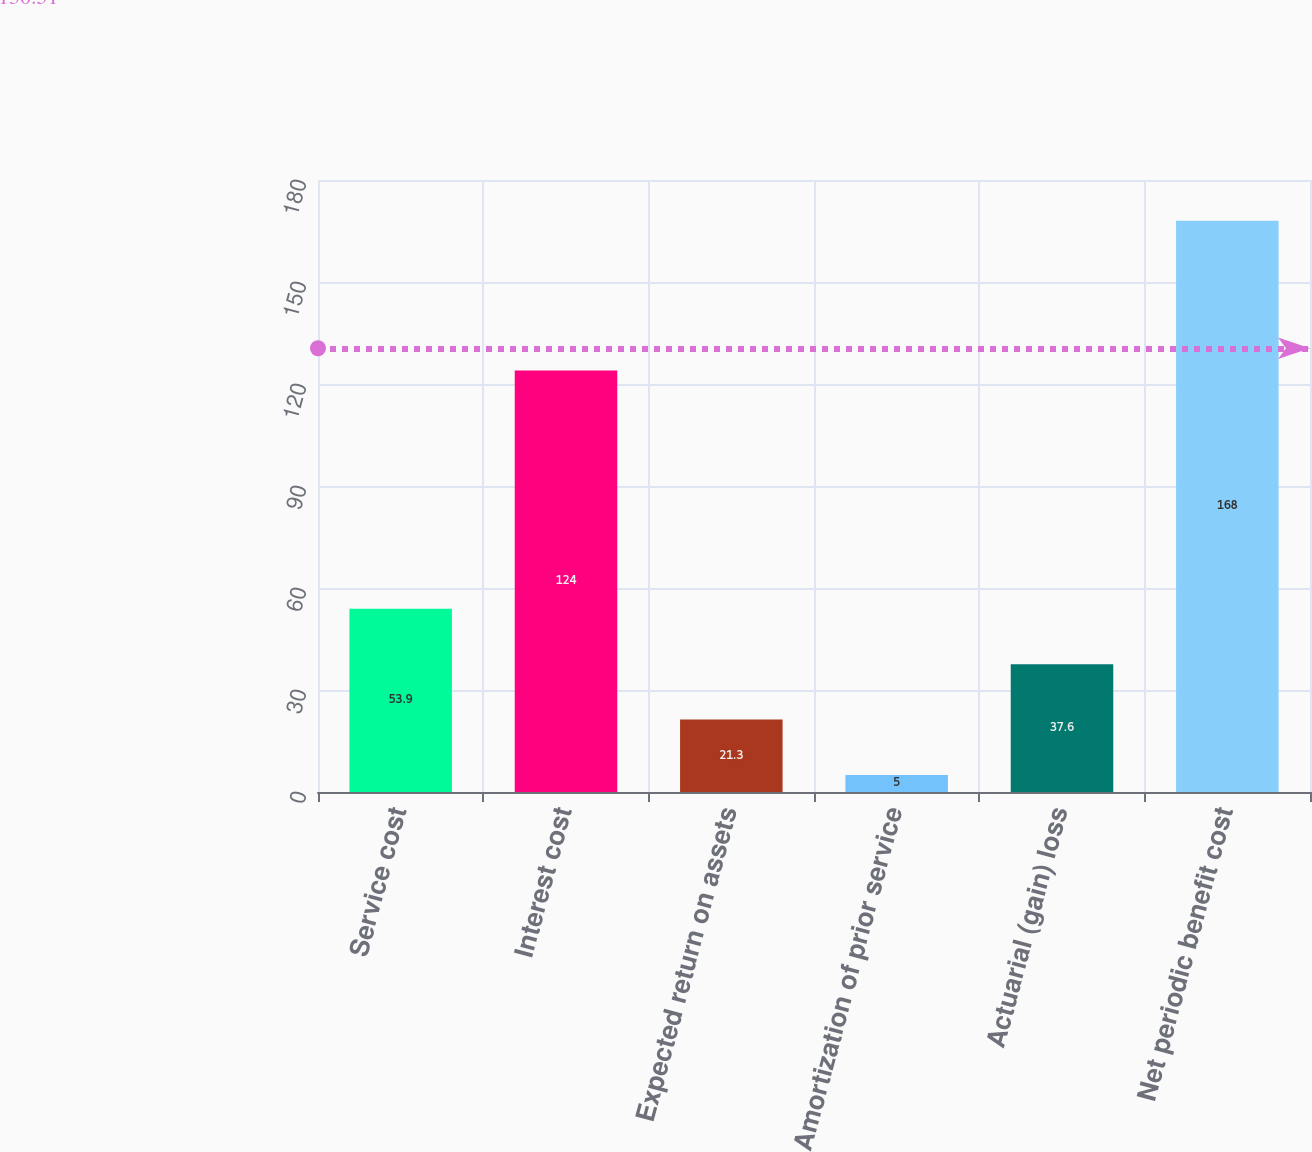<chart> <loc_0><loc_0><loc_500><loc_500><bar_chart><fcel>Service cost<fcel>Interest cost<fcel>Expected return on assets<fcel>Amortization of prior service<fcel>Actuarial (gain) loss<fcel>Net periodic benefit cost<nl><fcel>53.9<fcel>124<fcel>21.3<fcel>5<fcel>37.6<fcel>168<nl></chart> 